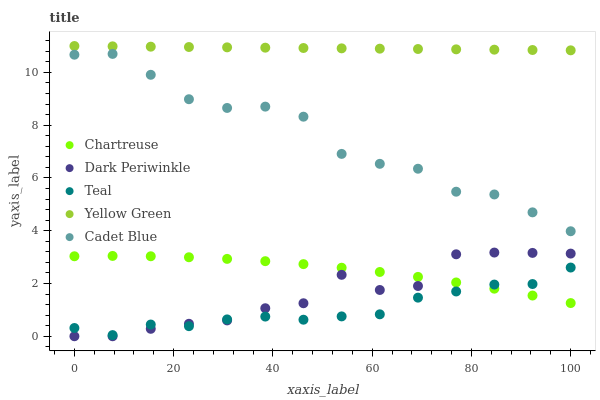Does Teal have the minimum area under the curve?
Answer yes or no. Yes. Does Yellow Green have the maximum area under the curve?
Answer yes or no. Yes. Does Cadet Blue have the minimum area under the curve?
Answer yes or no. No. Does Cadet Blue have the maximum area under the curve?
Answer yes or no. No. Is Yellow Green the smoothest?
Answer yes or no. Yes. Is Cadet Blue the roughest?
Answer yes or no. Yes. Is Dark Periwinkle the smoothest?
Answer yes or no. No. Is Dark Periwinkle the roughest?
Answer yes or no. No. Does Dark Periwinkle have the lowest value?
Answer yes or no. Yes. Does Cadet Blue have the lowest value?
Answer yes or no. No. Does Yellow Green have the highest value?
Answer yes or no. Yes. Does Cadet Blue have the highest value?
Answer yes or no. No. Is Chartreuse less than Cadet Blue?
Answer yes or no. Yes. Is Yellow Green greater than Cadet Blue?
Answer yes or no. Yes. Does Teal intersect Chartreuse?
Answer yes or no. Yes. Is Teal less than Chartreuse?
Answer yes or no. No. Is Teal greater than Chartreuse?
Answer yes or no. No. Does Chartreuse intersect Cadet Blue?
Answer yes or no. No. 